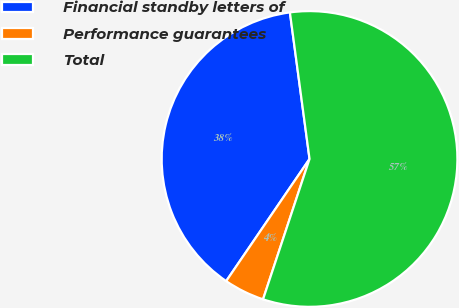Convert chart. <chart><loc_0><loc_0><loc_500><loc_500><pie_chart><fcel>Financial standby letters of<fcel>Performance guarantees<fcel>Total<nl><fcel>38.35%<fcel>4.44%<fcel>57.21%<nl></chart> 